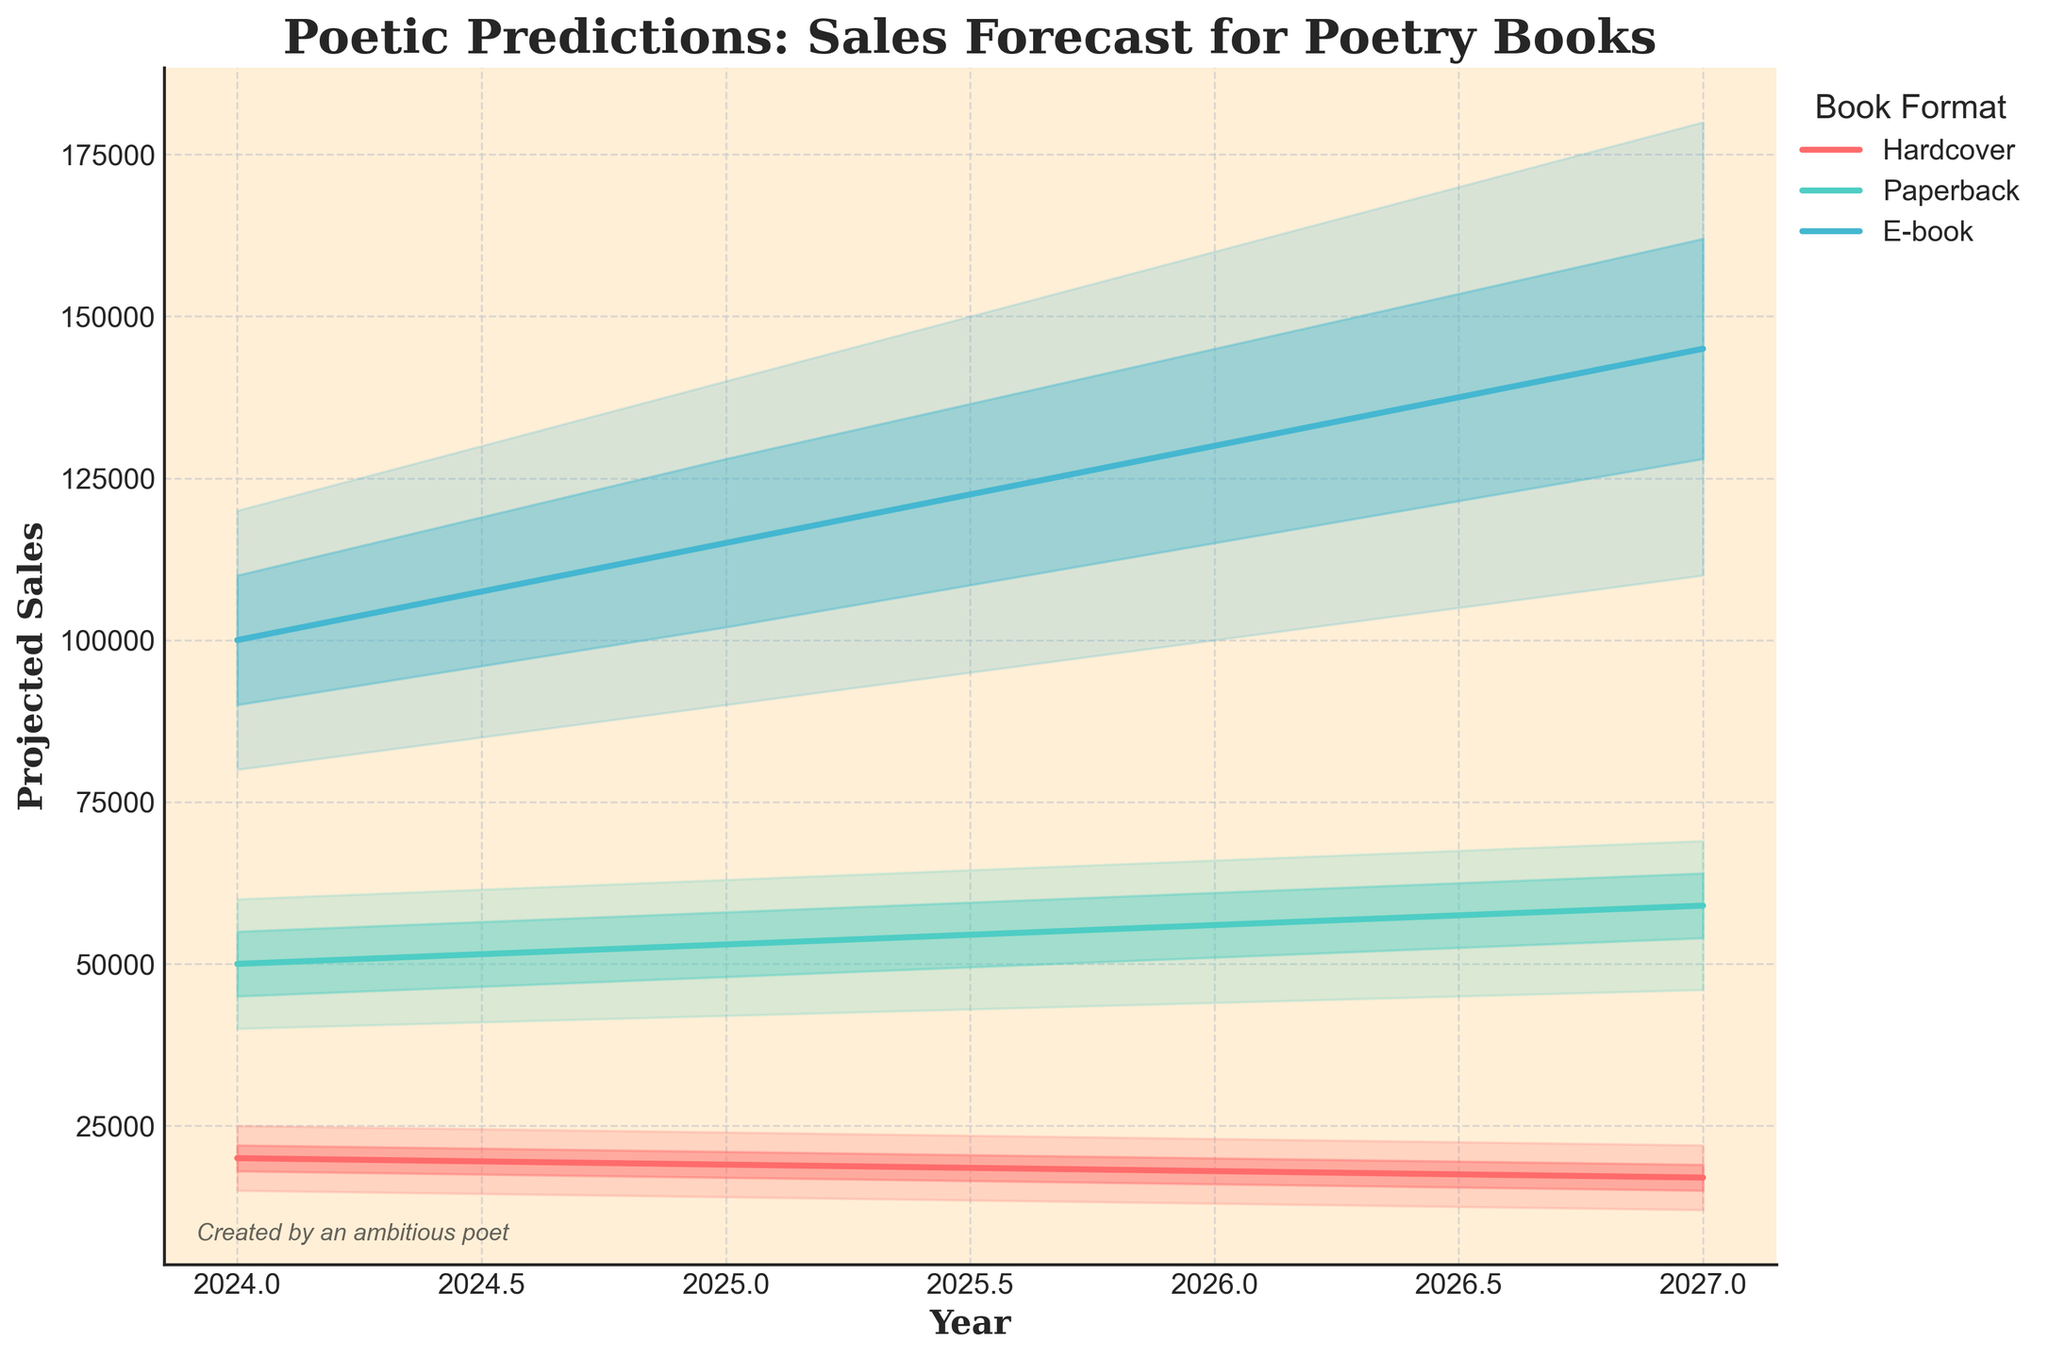What is the title of the chart? The title is usually at the top of the chart, displayed in bold for visibility. It can help viewers understand the context at a glance.
Answer: Poetic Predictions: Sales Forecast for Poetry Books What are the formats of poetry books displayed in the chart? The legend indicates the different formats represented in the chart, positioned typically to the right or bottom. The colors corresponding to these formats are also shown in the legend.
Answer: Hardcover, Paperback, E-book In what year is the highest projected sales for e-books, according to the high estimate? Follow the high (top) boundary of the fan for e-books (usually in a distinct color) and find the peak value and its associated year.
Answer: 2027 What is the difference between the high estimate and the low estimate for paperback books in 2025? Locate the high and low boundaries for paperback books in 2025, and compute the difference. High estimate is 63,000, and the low estimate is 42,000.
Answer: 21,000 How many years are projected in this chart? Count the distinct years displayed along the x-axis of the chart. This should give the total number of projected years.
Answer: 4 (2024, 2025, 2026, 2027) Which format shows the fastest growth in mid estimates from 2024 to 2027? Compare the mid estimates (central lines) across years for each format. Calculate the total growth for each and compare them. E-books grow from 100,000 in 2024 to 145,000 in 2027, showing the fastest growth.
Answer: E-book What is the average mid estimate for hardcover books from 2024 to 2027? Sum the mid estimates for hardcover books over all four years and divide by the number of years (4). The values are 20,000, 19,000, 18,000, and 17,000.
Answer: 18,500 In which year are paperback sales estimated to be closest to 50,000 in the mid estimate? Check the mid estimates (central lines) for each year and compare them to 50,000 for paperback books.
Answer: 2024 Between hardcover and paperback books, which has a lower mid estimate in 2026? Compare the mid estimates for hardcover and paperback books in 2026. Hardcover is 18,000 while paperback is 56,000.
Answer: Hardcover How does the forecasted trend for e-books' high estimates compare to that of hardcover books from 2024 to 2027? Examine the high boundaries of both e-books and hardcover books and describe the trend over the years. E-books show an increasing trend peaking at 180,000 in 2027, while hardcover books peak at 25,000 in 2024 and decrease to 22,000 by 2027.
Answer: E-books increase, Hardcover decreases 